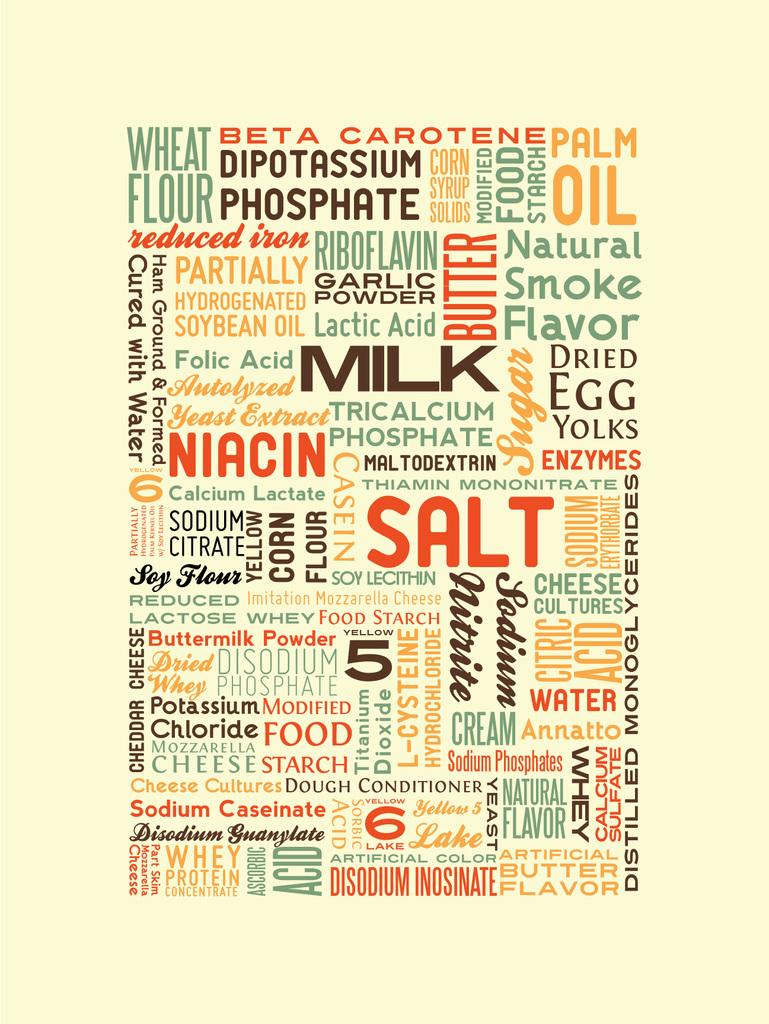<image>
Provide a brief description of the given image. Collage of words with a large red word that says Salt near the middle. 